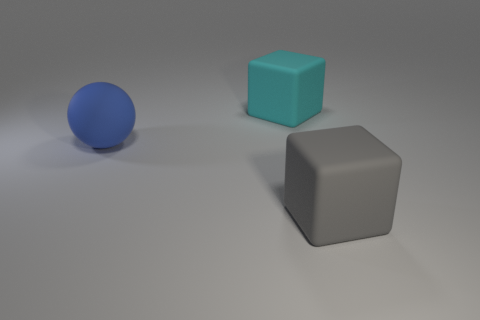Are any big cyan matte things visible?
Make the answer very short. Yes. Are there any big green blocks that have the same material as the large cyan cube?
Offer a terse response. No. Is the number of large cubes that are right of the cyan block greater than the number of matte blocks to the right of the large gray rubber thing?
Provide a succinct answer. Yes. Do the blue sphere and the cyan rubber cube have the same size?
Your response must be concise. Yes. The rubber thing that is right of the block left of the big gray matte cube is what color?
Offer a very short reply. Gray. What is the color of the big matte ball?
Provide a succinct answer. Blue. How many objects are big matte blocks that are to the right of the cyan object or big red shiny spheres?
Keep it short and to the point. 1. There is a big blue sphere; are there any big gray matte things to the right of it?
Your response must be concise. Yes. Are there any large cyan matte blocks on the left side of the large rubber cube behind the large block that is in front of the large cyan matte cube?
Your response must be concise. No. What number of cubes are either tiny gray metal things or big blue matte things?
Offer a very short reply. 0. 